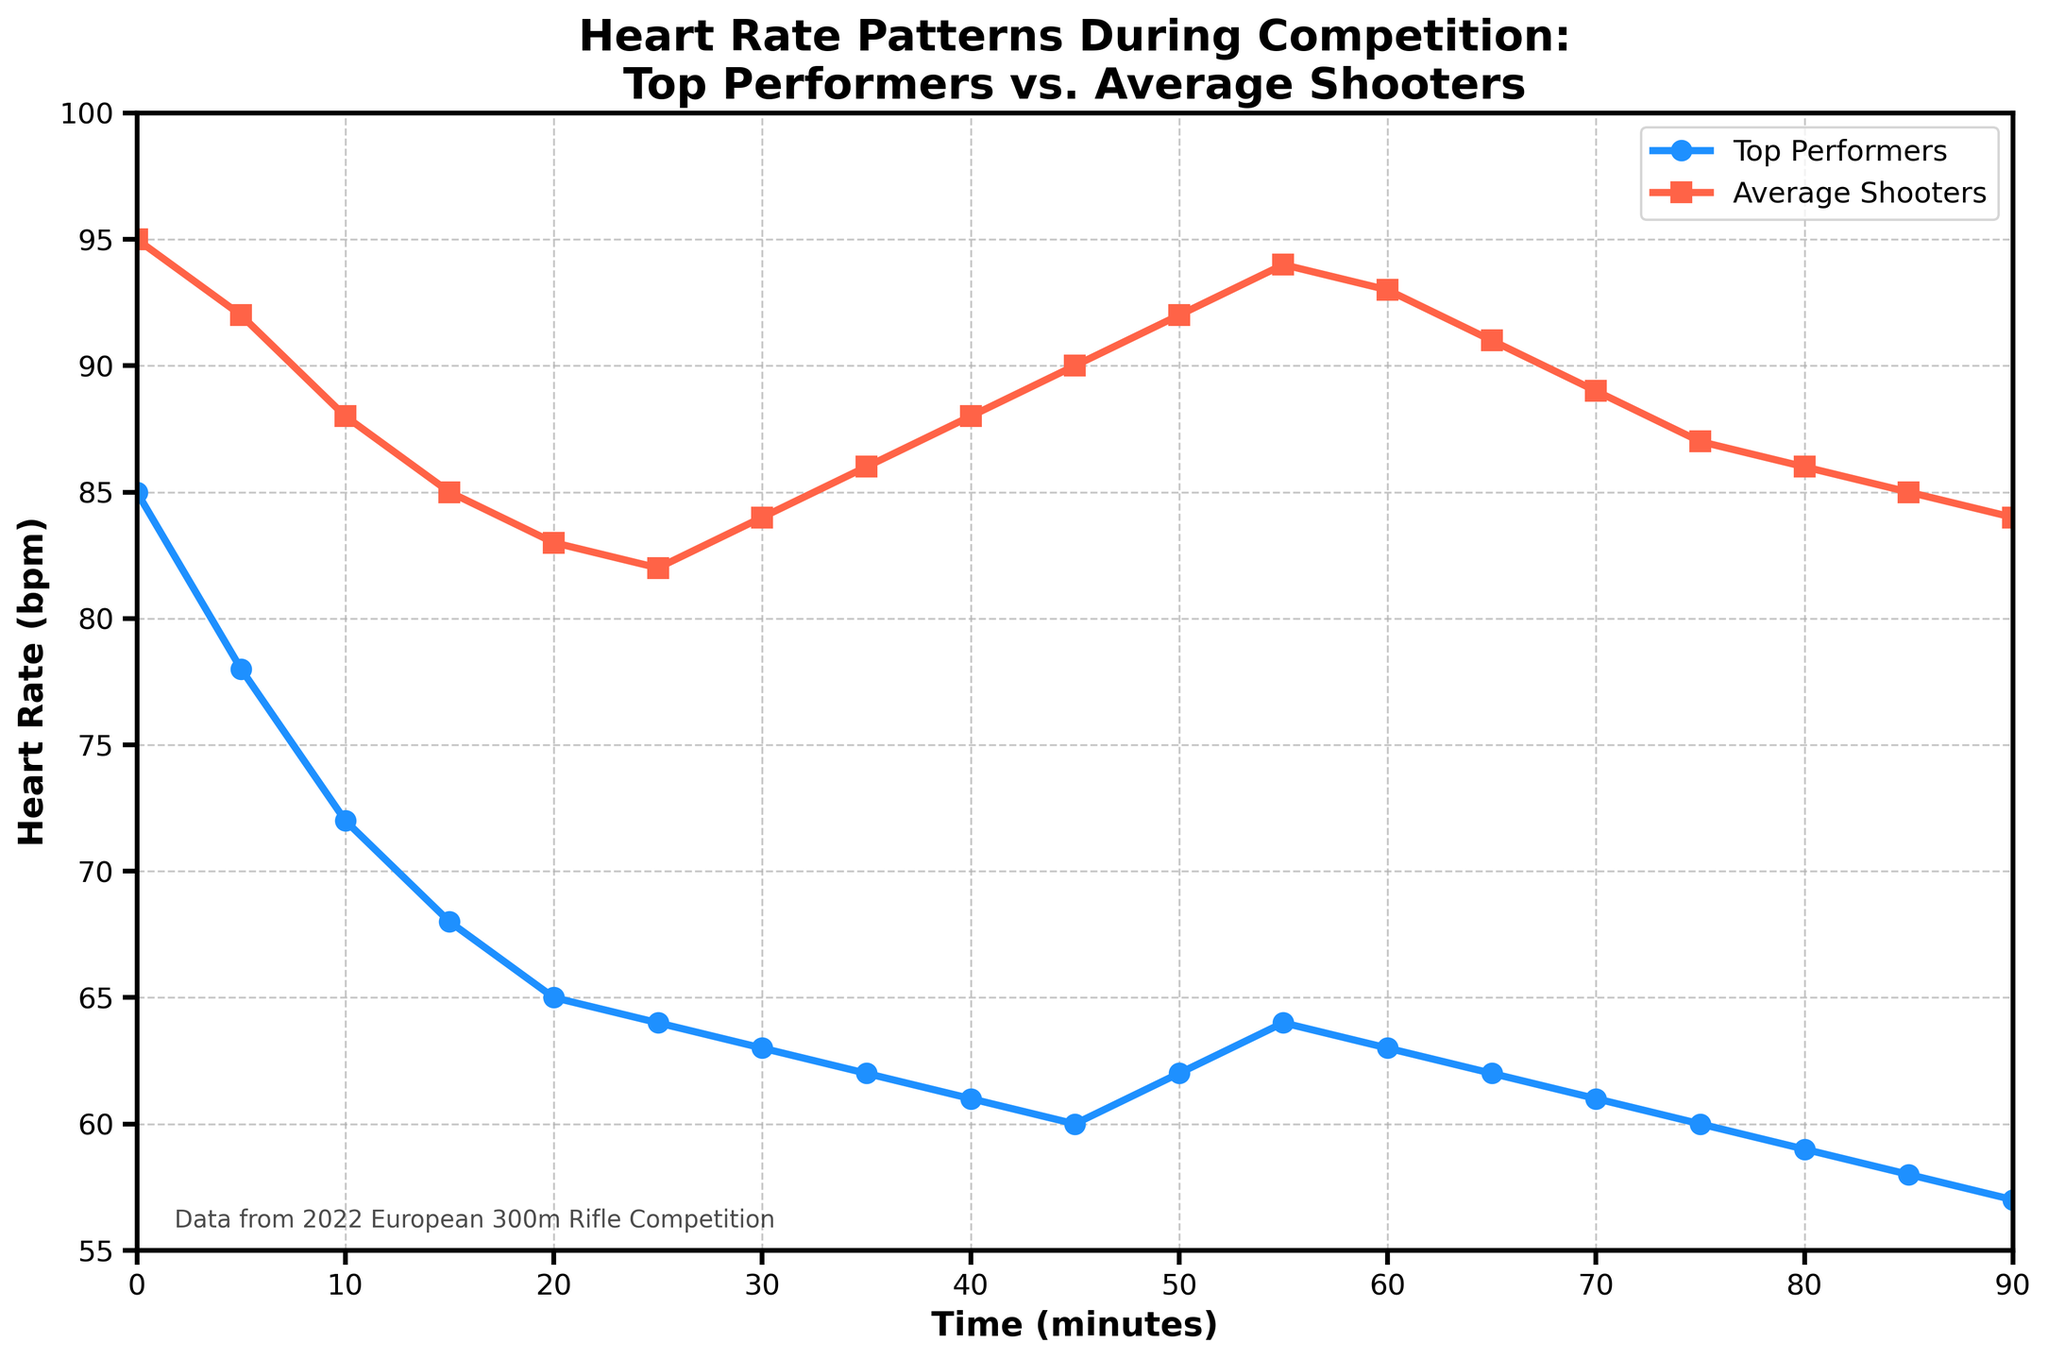Which group starts with a higher heart rate and by how much? At time 0 minutes, compare the heart rates of Top Performers (85 bpm) and Average Shooters (95 bpm). Subtract the heart rate of Top Performers from Average Shooters: 95 - 85.
Answer: Average Shooters by 10 bpm From minute 15 to minute 30, how does the heart rate of Top Performers change? Look at the heart rate of Top Performers at minute 15 (68 bpm) and minute 30 (63 bpm). Subtract the heart rate at 30 minutes from that at 15 minutes: 68 - 63.
Answer: Decreases by 5 bpm What's the lowest heart rate recorded for Average Shooters and at what time does it occur? Identify the minimum heart rate for Average Shooters from the data, which is 82 bpm at 25 minutes.
Answer: 82 bpm at 25 minutes Do the heart rates of Top Performers or Average Shooters ever increase after initially decreasing? Observe the trend of the heart rate lines. For Top Performers, the heart rate increases slightly from 50 minutes to 55 minutes. For Average Shooters, it continuously decreases until 25 minutes and increases at 30 minutes, and then fluctuates around 84-95 bpm later.
Answer: Both groups At what time do the heart rates of both groups approach closest to each other? Identify the time when the difference between the heart rates of both groups is minimum by comparing the values. At 30 minutes, the Top Performers have 63 bpm and the Average Shooters have 84 bpm, with a difference of 21 bpm.
Answer: Close at 85 minutes with a difference of 1 bpm What is the trend of the heart rate of Average Shooters between 55 minutes and 90 minutes? Observe the heart rate values for Average Shooters from 55 to 90 minutes. The heart rate starts from 94 bpm at 55 minutes, decreases to 84 bpm at 90 minutes.
Answer: Decreasing trend At what time does the heart rate of Top Performers first reach below 60 bpm? Identify the first instance when the heart rate of Top Performers is below 60 bpm, which occurs at 80 minutes with a heart rate of 59 bpm.
Answer: 80 minutes How do the heart rates of both groups compare at the end of the competition? Look at the heart rates at 90 minutes for both groups: Top Performers have 57 bpm and Average Shooters have 84 bpm. Subtract Top Performers' heart rate from Average Shooters': 84 - 57.
Answer: Average Shooters by 27 bpm 